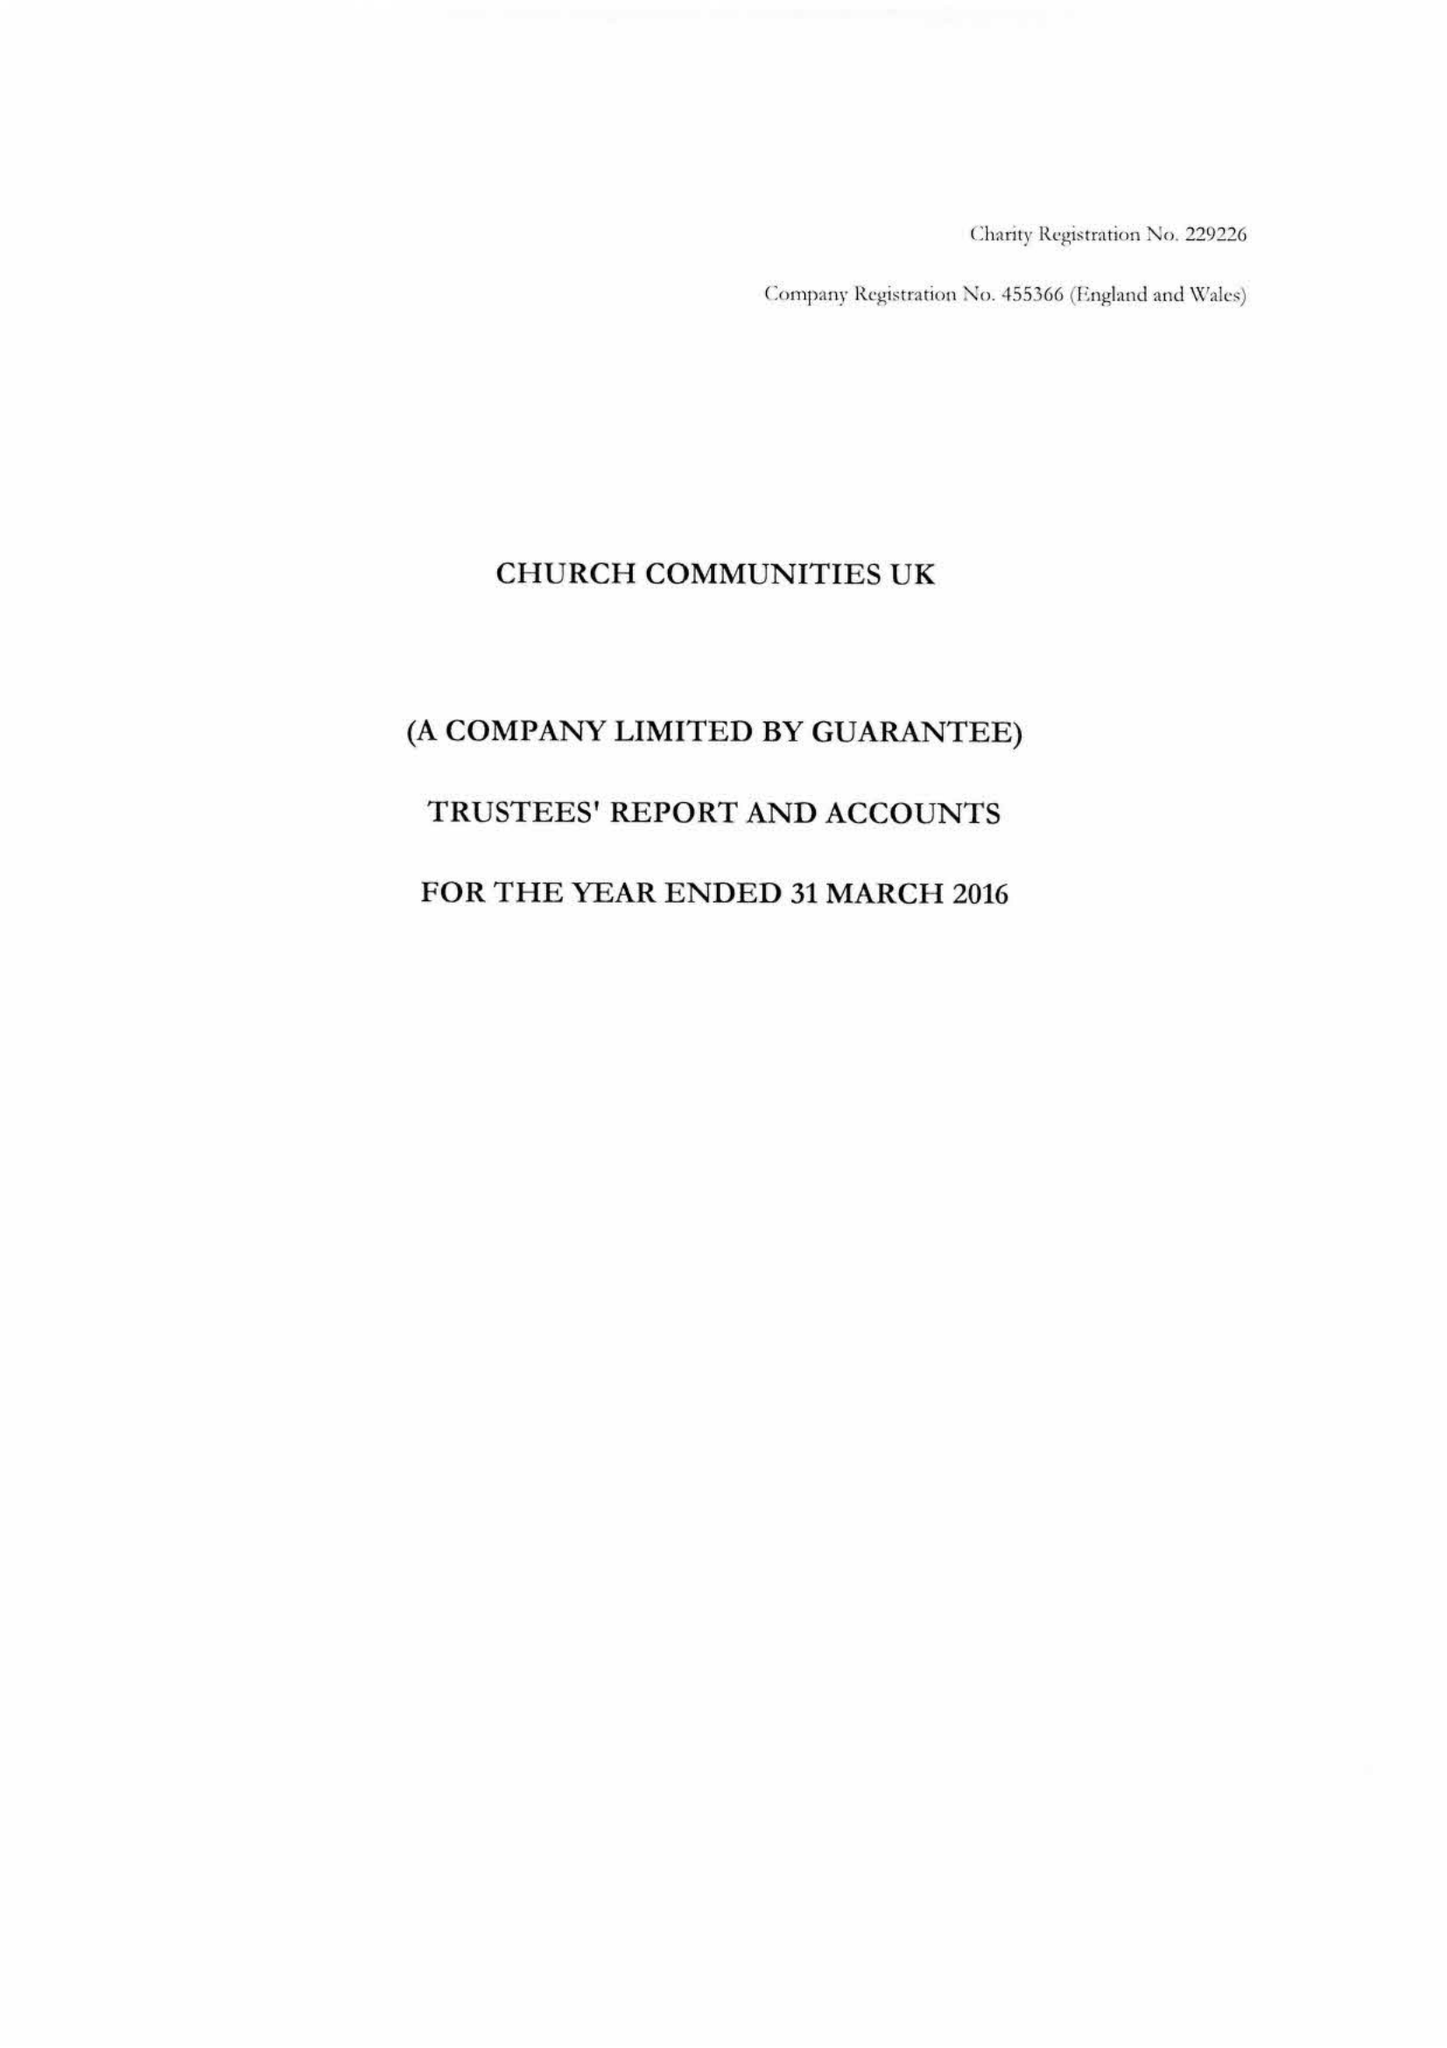What is the value for the charity_number?
Answer the question using a single word or phrase. 229226 